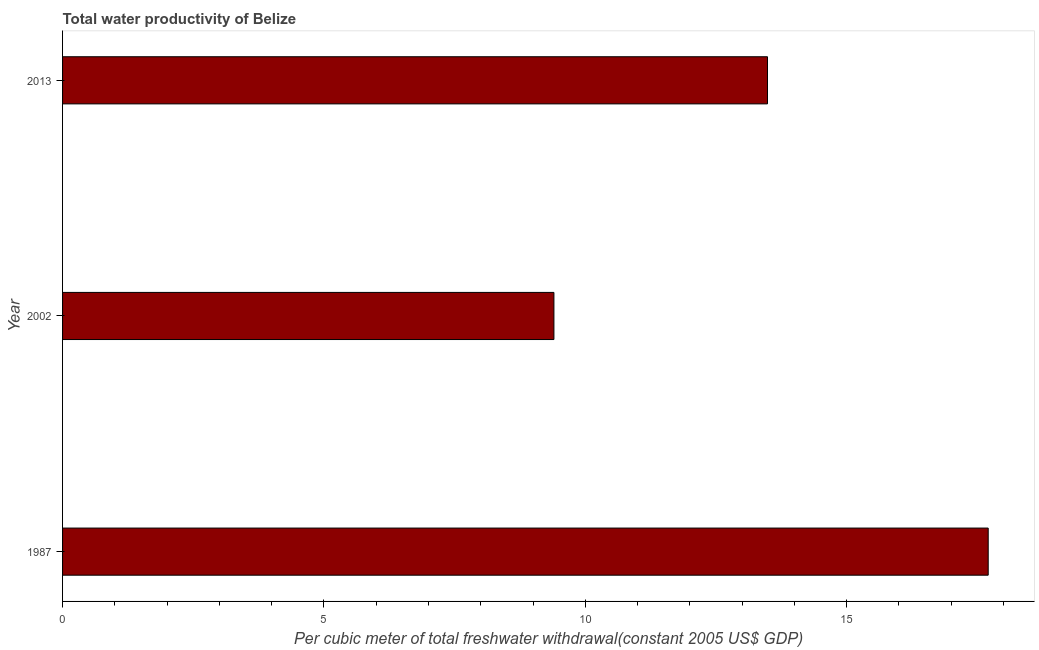What is the title of the graph?
Provide a short and direct response. Total water productivity of Belize. What is the label or title of the X-axis?
Ensure brevity in your answer.  Per cubic meter of total freshwater withdrawal(constant 2005 US$ GDP). What is the label or title of the Y-axis?
Your answer should be very brief. Year. What is the total water productivity in 2002?
Your response must be concise. 9.4. Across all years, what is the maximum total water productivity?
Offer a terse response. 17.71. Across all years, what is the minimum total water productivity?
Keep it short and to the point. 9.4. In which year was the total water productivity maximum?
Keep it short and to the point. 1987. What is the sum of the total water productivity?
Keep it short and to the point. 40.59. What is the difference between the total water productivity in 2002 and 2013?
Your answer should be compact. -4.09. What is the average total water productivity per year?
Provide a succinct answer. 13.53. What is the median total water productivity?
Make the answer very short. 13.49. What is the ratio of the total water productivity in 2002 to that in 2013?
Your response must be concise. 0.7. What is the difference between the highest and the second highest total water productivity?
Provide a succinct answer. 4.22. Is the sum of the total water productivity in 2002 and 2013 greater than the maximum total water productivity across all years?
Provide a succinct answer. Yes. What is the difference between the highest and the lowest total water productivity?
Your answer should be very brief. 8.31. In how many years, is the total water productivity greater than the average total water productivity taken over all years?
Keep it short and to the point. 1. How many bars are there?
Offer a very short reply. 3. Are all the bars in the graph horizontal?
Offer a terse response. Yes. How many years are there in the graph?
Keep it short and to the point. 3. What is the Per cubic meter of total freshwater withdrawal(constant 2005 US$ GDP) in 1987?
Offer a terse response. 17.71. What is the Per cubic meter of total freshwater withdrawal(constant 2005 US$ GDP) of 2002?
Offer a very short reply. 9.4. What is the Per cubic meter of total freshwater withdrawal(constant 2005 US$ GDP) of 2013?
Provide a succinct answer. 13.49. What is the difference between the Per cubic meter of total freshwater withdrawal(constant 2005 US$ GDP) in 1987 and 2002?
Give a very brief answer. 8.31. What is the difference between the Per cubic meter of total freshwater withdrawal(constant 2005 US$ GDP) in 1987 and 2013?
Your answer should be very brief. 4.22. What is the difference between the Per cubic meter of total freshwater withdrawal(constant 2005 US$ GDP) in 2002 and 2013?
Provide a succinct answer. -4.09. What is the ratio of the Per cubic meter of total freshwater withdrawal(constant 2005 US$ GDP) in 1987 to that in 2002?
Make the answer very short. 1.88. What is the ratio of the Per cubic meter of total freshwater withdrawal(constant 2005 US$ GDP) in 1987 to that in 2013?
Offer a terse response. 1.31. What is the ratio of the Per cubic meter of total freshwater withdrawal(constant 2005 US$ GDP) in 2002 to that in 2013?
Provide a succinct answer. 0.7. 